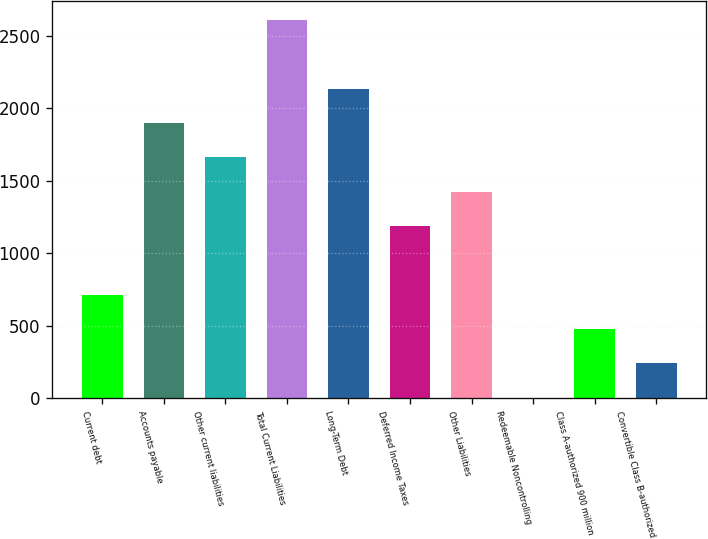<chart> <loc_0><loc_0><loc_500><loc_500><bar_chart><fcel>Current debt<fcel>Accounts payable<fcel>Other current liabilities<fcel>Total Current Liabilities<fcel>Long-Term Debt<fcel>Deferred Income Taxes<fcel>Other Liabilities<fcel>Redeemable Noncontrolling<fcel>Class A-authorized 900 million<fcel>Convertible Class B-authorized<nl><fcel>715.32<fcel>1900.12<fcel>1663.16<fcel>2611<fcel>2137.08<fcel>1189.24<fcel>1426.2<fcel>4.44<fcel>478.36<fcel>241.4<nl></chart> 